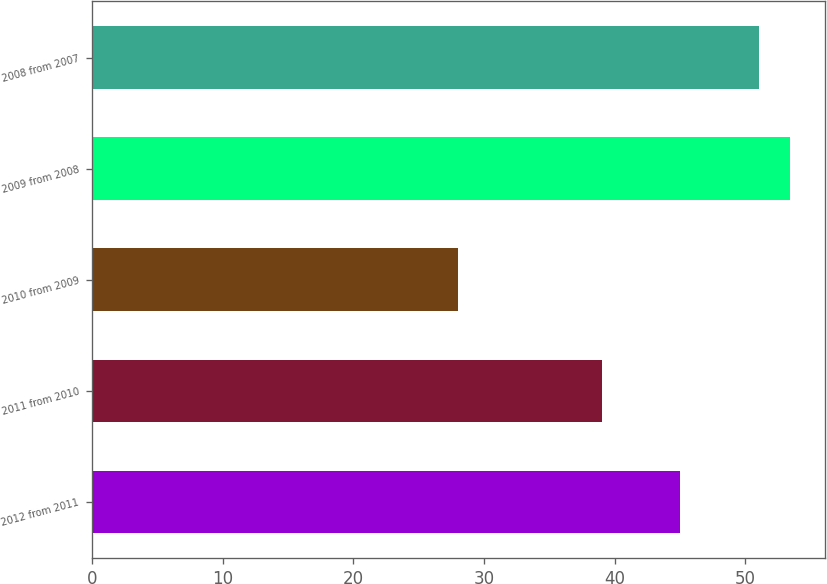Convert chart to OTSL. <chart><loc_0><loc_0><loc_500><loc_500><bar_chart><fcel>2012 from 2011<fcel>2011 from 2010<fcel>2010 from 2009<fcel>2009 from 2008<fcel>2008 from 2007<nl><fcel>45<fcel>39<fcel>28<fcel>53.4<fcel>51<nl></chart> 